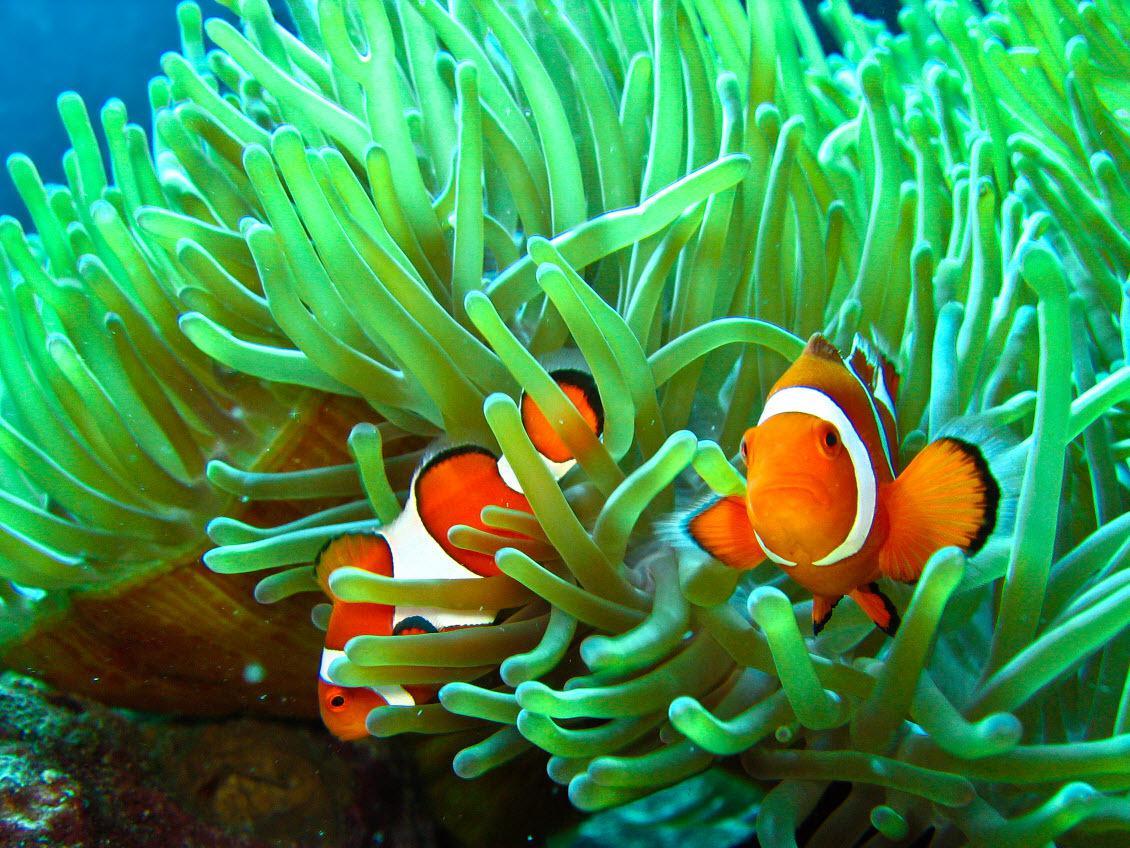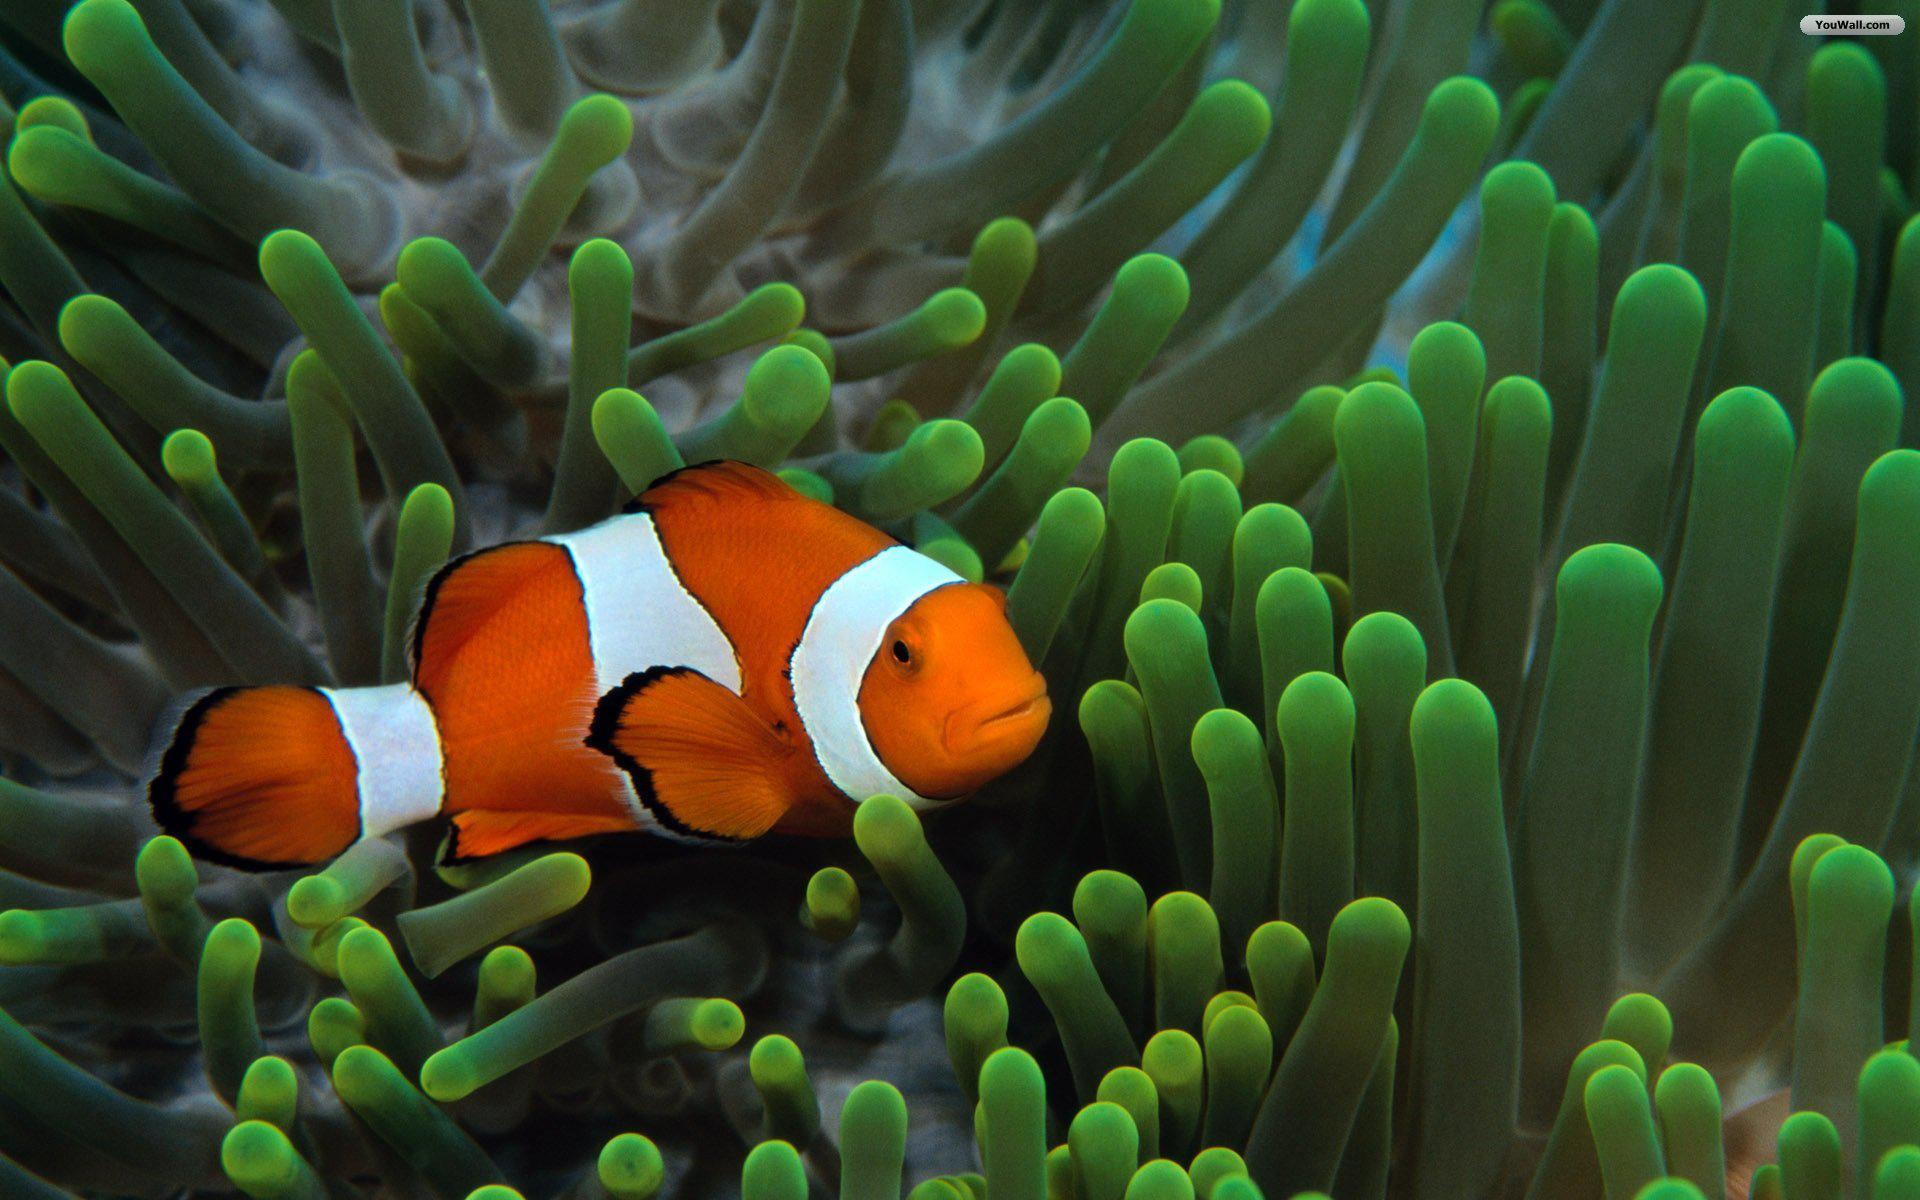The first image is the image on the left, the second image is the image on the right. Examine the images to the left and right. Is the description "Each image shows orange-and-white clown fish swimming among slender green anemone tendrils." accurate? Answer yes or no. Yes. The first image is the image on the left, the second image is the image on the right. Assess this claim about the two images: "There is exactly one fish in the right image.". Correct or not? Answer yes or no. Yes. 